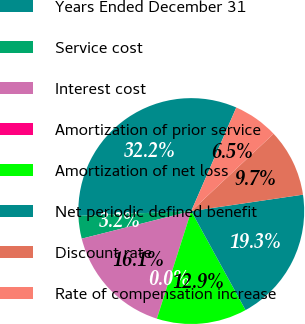Convert chart. <chart><loc_0><loc_0><loc_500><loc_500><pie_chart><fcel>Years Ended December 31<fcel>Service cost<fcel>Interest cost<fcel>Amortization of prior service<fcel>Amortization of net loss<fcel>Net periodic defined benefit<fcel>Discount rate<fcel>Rate of compensation increase<nl><fcel>32.21%<fcel>3.25%<fcel>16.12%<fcel>0.03%<fcel>12.9%<fcel>19.34%<fcel>9.68%<fcel>6.47%<nl></chart> 